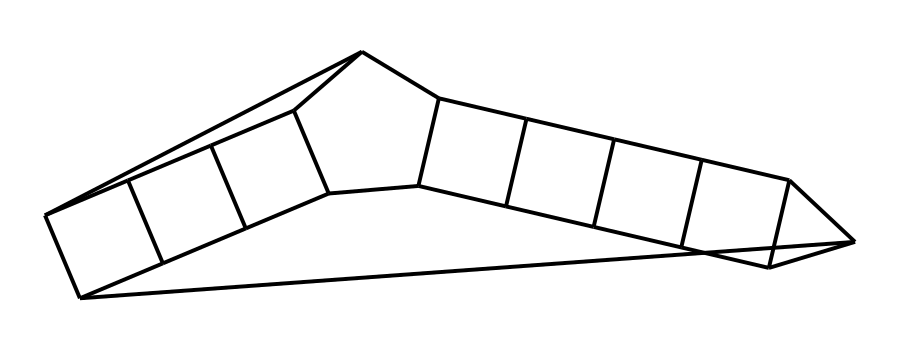What is the molecular formula of dodecahedrane? Dodecahedrane consists of 12 carbon atoms and 24 hydrogen atoms, which can be deduced by counting the number of carbon (C) and hydrogen (H) atoms in the structure and recognizing that dodecahedrane is a saturated hydrocarbon.
Answer: C12H24 How many faces does the dodecahedrane molecule have? Dodecahedrane is a polyhedron with 12 faces, corresponding to its name (dodeca- meaning twelve), and this is a characteristic of its cage structure.
Answer: 12 What type of symmetry does dodecahedrane exhibit? Dodecahedrane exhibits high symmetry, specifically icosahedral symmetry, which means that it is invariant under various rotations and reflections due to its regular geometric structure.
Answer: icosahedral What is the primary application area of dodecahedrane? Dodecahedrane is primarily researched for its potential applications in materials science, particularly in creating novel materials with unique properties due to its cage-like structure.
Answer: materials science How many hydrogen atoms are attached to each carbon in dodecahedrane? In dodecahedrane, each carbon atom is bonded to two hydrogen atoms. This can be inferred from the molecular saturation and the structure of the carbon cages where each carbon fulfills its tetravalency.
Answer: 2 What structural feature distinguishes cage compounds like dodecahedrane? Cage compounds like dodecahedrane are distinguished by their enclosed three-dimensional frameworks, essentially forming a "cage" structure that traps a specific volume of space.
Answer: enclosed frameworks 